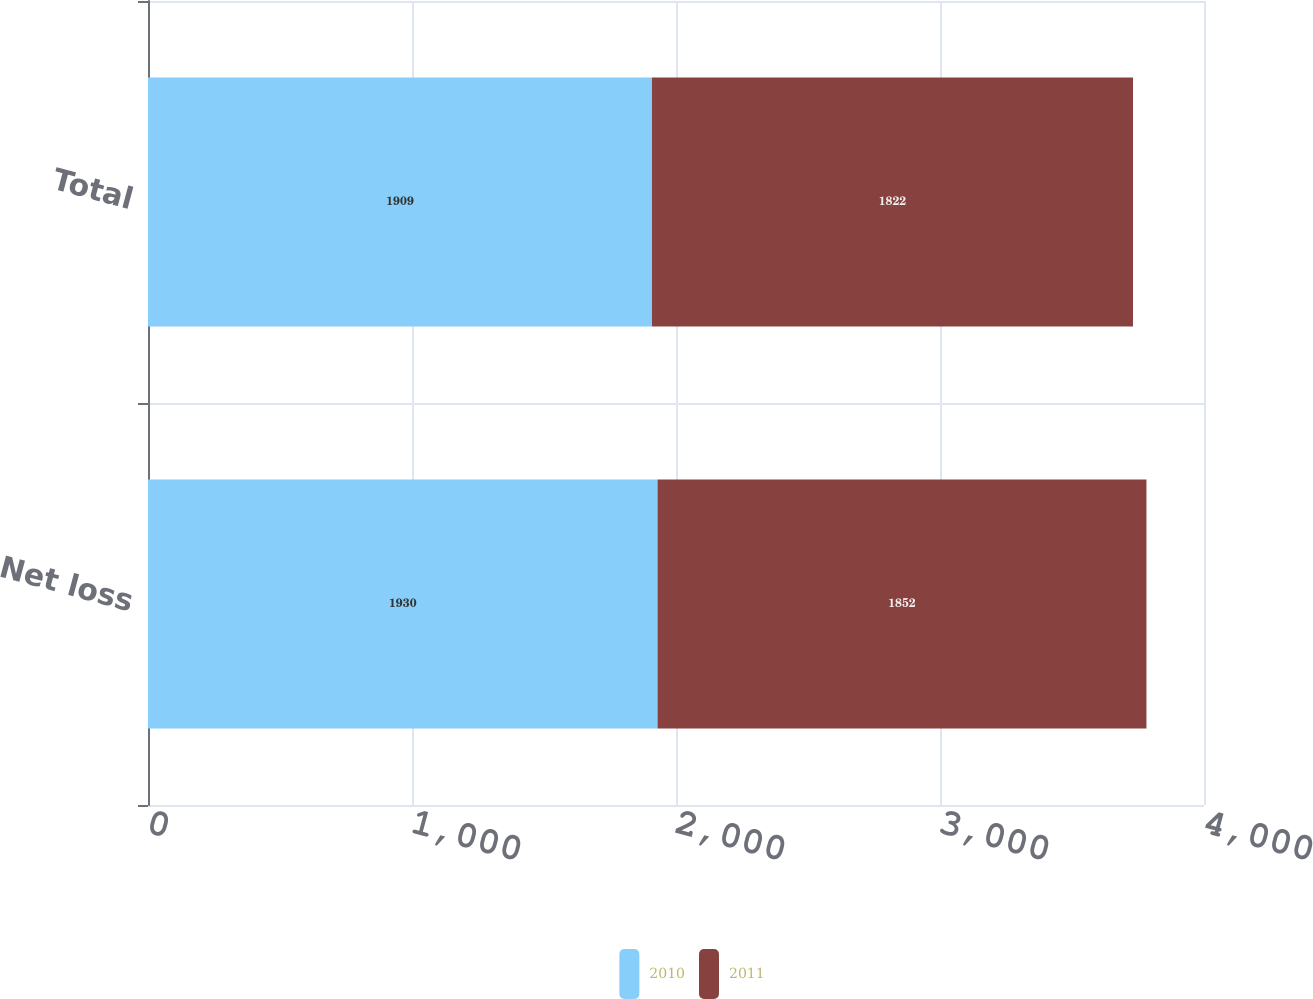Convert chart. <chart><loc_0><loc_0><loc_500><loc_500><stacked_bar_chart><ecel><fcel>Net loss<fcel>Total<nl><fcel>2010<fcel>1930<fcel>1909<nl><fcel>2011<fcel>1852<fcel>1822<nl></chart> 